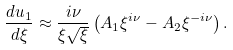<formula> <loc_0><loc_0><loc_500><loc_500>\frac { d u _ { 1 } } { d \xi } \approx \frac { i \nu } { \xi \sqrt { \xi } } \left ( A _ { 1 } \xi ^ { i \nu } - A _ { 2 } \xi ^ { - i \nu } \right ) .</formula> 